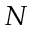<formula> <loc_0><loc_0><loc_500><loc_500>N</formula> 